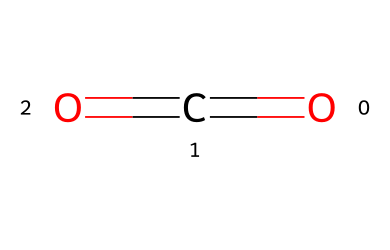What is the name of this chemical? The SMILES representation provided corresponds to a structure with one carbon atom and two oxygen atoms, which is known as carbon dioxide.
Answer: carbon dioxide How many atoms are present in this molecule? The structure contains one carbon atom and two oxygen atoms, totaling three atoms.
Answer: 3 How many double bonds are in this compound? The structure shows that there is one double bond between the carbon and each of the two oxygen atoms, resulting in two double bonds.
Answer: 2 What is the molecular formula for this chemical? Given the elemental composition, one carbon and two oxygen atoms yield the molecular formula CO2.
Answer: CO2 Does this gas contribute to water acidification? Carbon dioxide when dissolved in water forms carbonic acid, which lowers pH and causes acidification.
Answer: Yes What type of bonding occurs in this molecule? The carbon atom forms double bonds with each oxygen atom, indicating the presence of covalent bonding in this molecule.
Answer: covalent What is the primary impact of this gas on aquatic ecosystems? The presence of carbon dioxide in water leads to acidification, which can harm aquatic life, particularly organisms with calcium carbonate shells.
Answer: acidification 